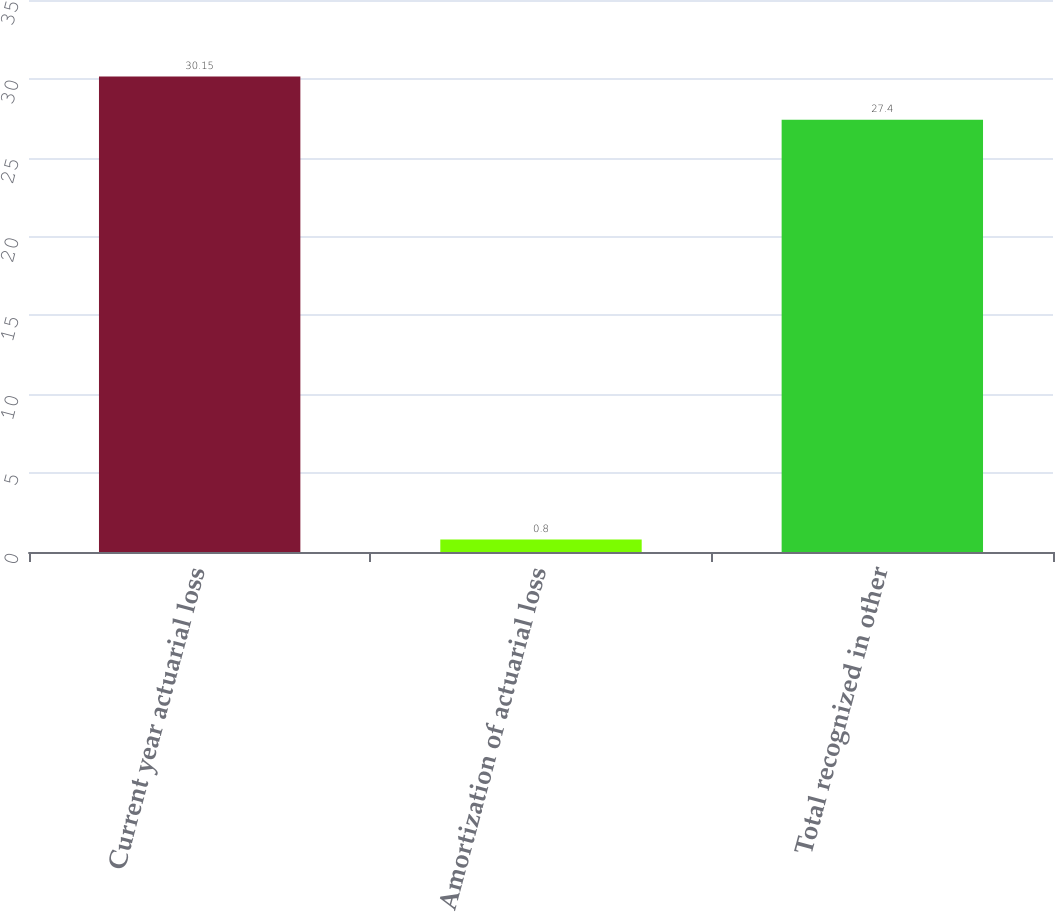Convert chart. <chart><loc_0><loc_0><loc_500><loc_500><bar_chart><fcel>Current year actuarial loss<fcel>Amortization of actuarial loss<fcel>Total recognized in other<nl><fcel>30.15<fcel>0.8<fcel>27.4<nl></chart> 